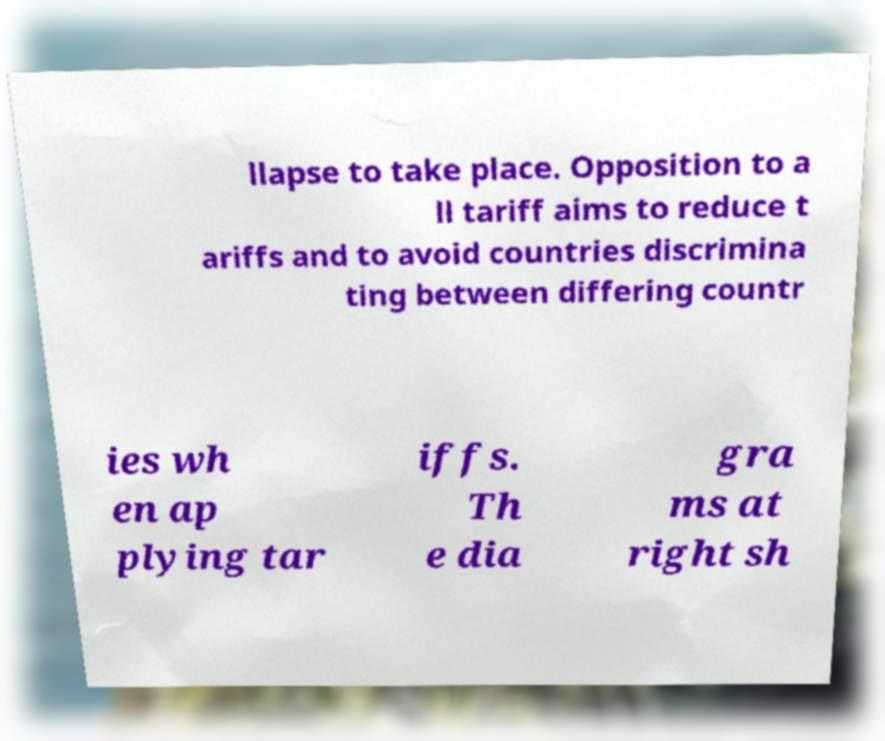Could you extract and type out the text from this image? llapse to take place. Opposition to a ll tariff aims to reduce t ariffs and to avoid countries discrimina ting between differing countr ies wh en ap plying tar iffs. Th e dia gra ms at right sh 